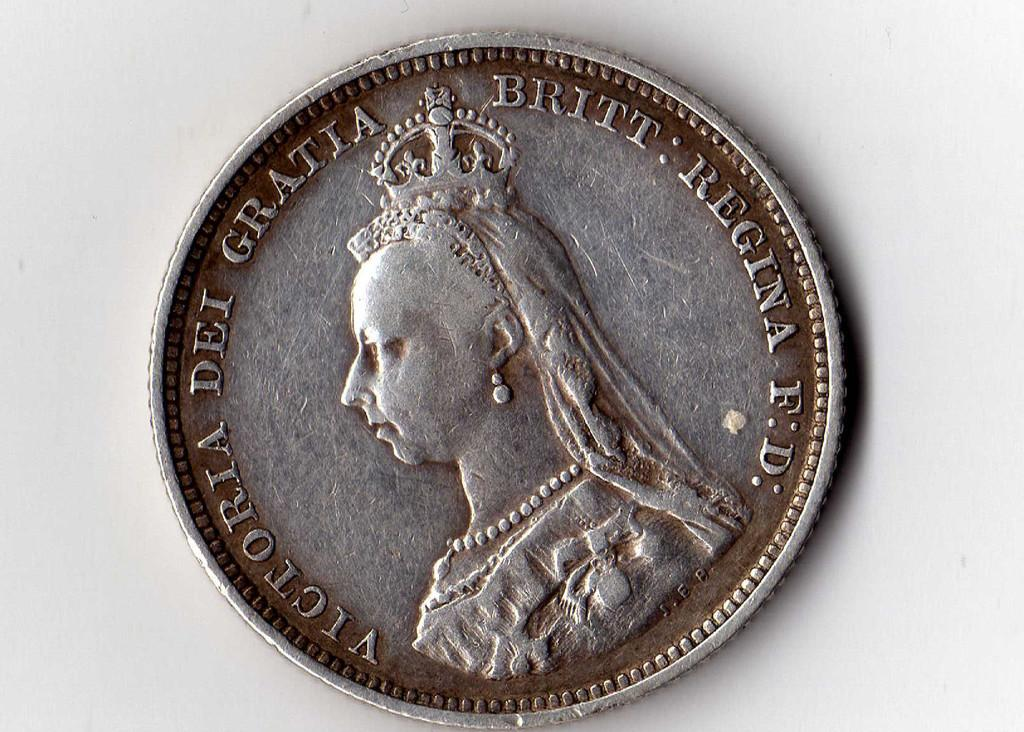<image>
Write a terse but informative summary of the picture. a silver coin that says 'victoria dei gratia britt regina f.d.' 